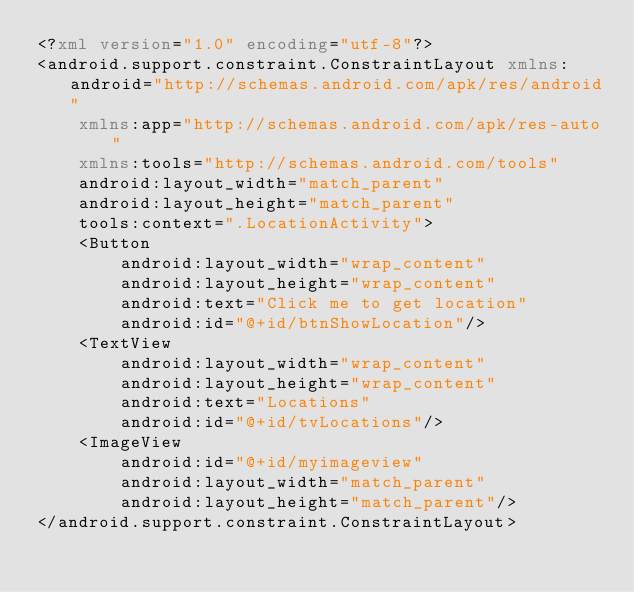Convert code to text. <code><loc_0><loc_0><loc_500><loc_500><_XML_><?xml version="1.0" encoding="utf-8"?>
<android.support.constraint.ConstraintLayout xmlns:android="http://schemas.android.com/apk/res/android"
    xmlns:app="http://schemas.android.com/apk/res-auto"
    xmlns:tools="http://schemas.android.com/tools"
    android:layout_width="match_parent"
    android:layout_height="match_parent"
    tools:context=".LocationActivity">
    <Button
        android:layout_width="wrap_content"
        android:layout_height="wrap_content"
        android:text="Click me to get location"
        android:id="@+id/btnShowLocation"/>
    <TextView
        android:layout_width="wrap_content"
        android:layout_height="wrap_content"
        android:text="Locations"
        android:id="@+id/tvLocations"/>
    <ImageView
        android:id="@+id/myimageview"
        android:layout_width="match_parent"
        android:layout_height="match_parent"/>
</android.support.constraint.ConstraintLayout></code> 